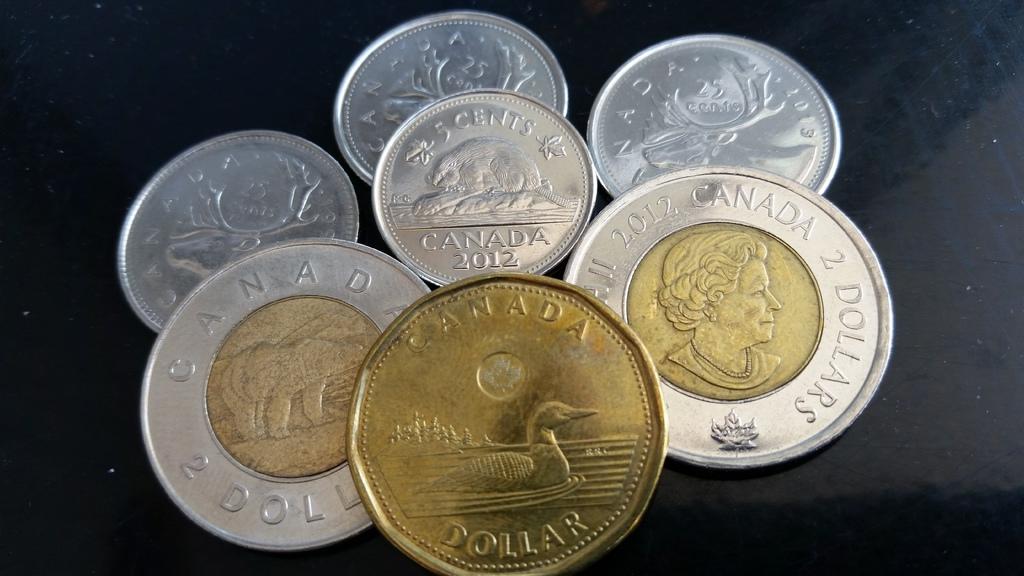Whats the currency of the coins?
Keep it short and to the point. Dollar. What country does these coins come from?
Your response must be concise. Canada. 